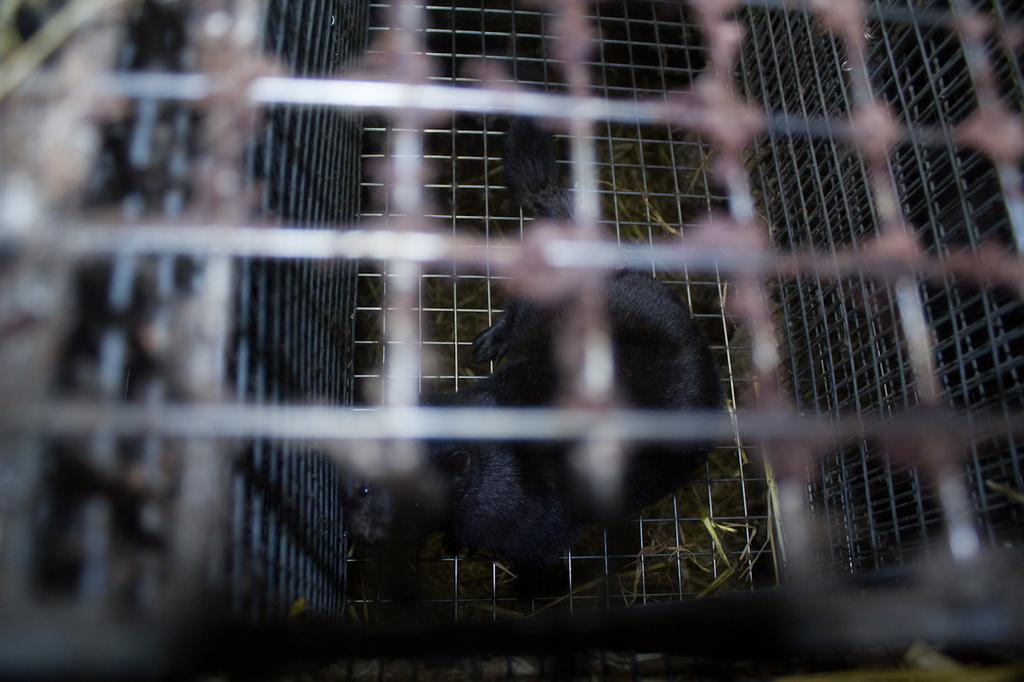What type of animal is present in the image? There is an animal in the image, but the specific type is not mentioned in the facts. Where is the animal located in the image? The animal is in a cafe. What is the animal doing with its chin in the image? There is no chin mentioned in the image, as it only states that there is an animal in a cafe. 